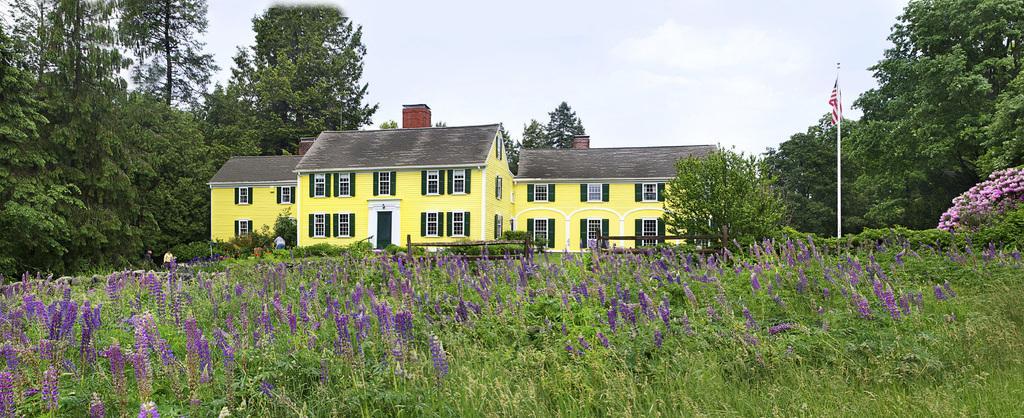Describe this image in one or two sentences. In this picture we can see plants with flowers, flag, pole, fence, trees, houses with windows, door and some people and in the background we can see the sky. 